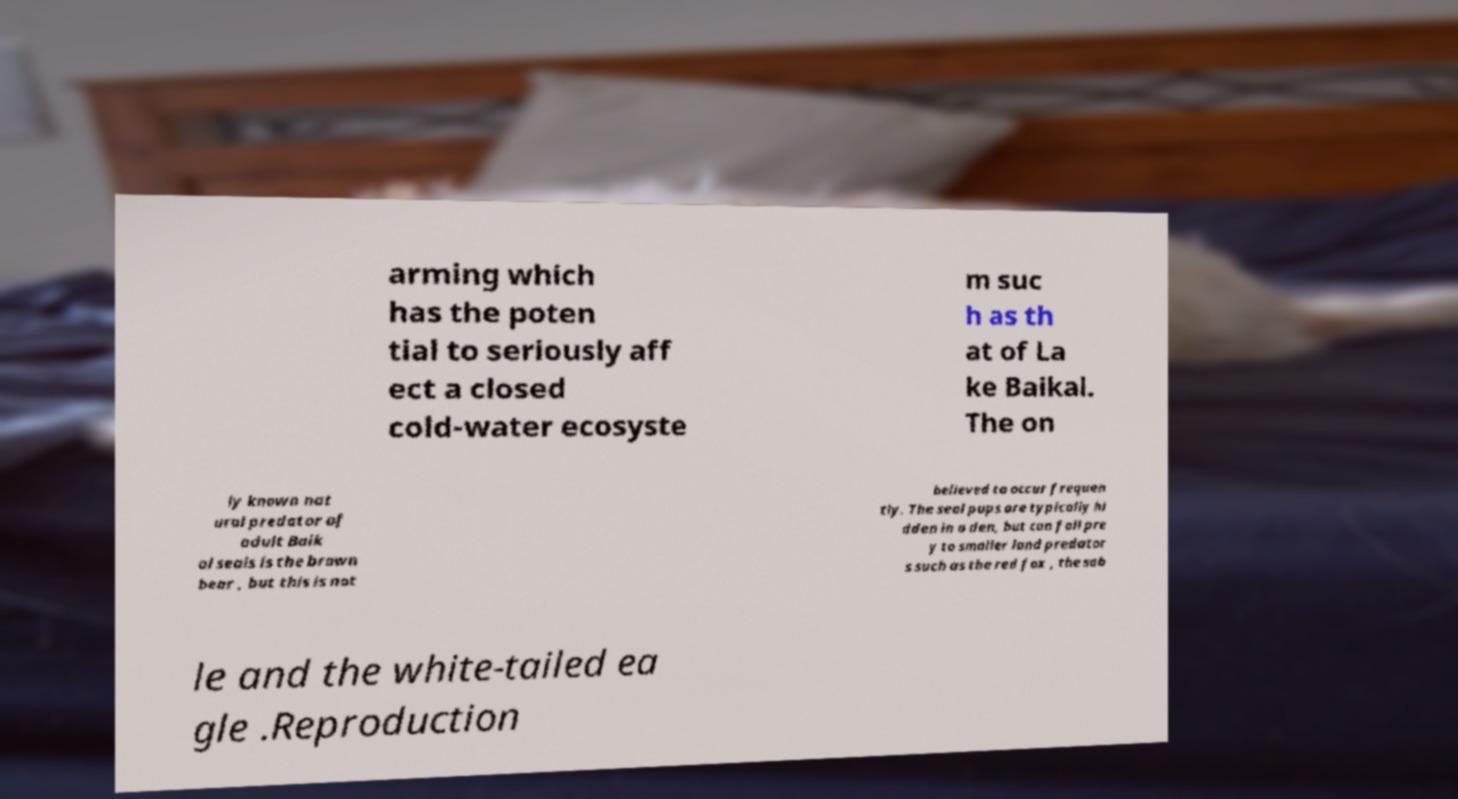Can you accurately transcribe the text from the provided image for me? arming which has the poten tial to seriously aff ect a closed cold-water ecosyste m suc h as th at of La ke Baikal. The on ly known nat ural predator of adult Baik al seals is the brown bear , but this is not believed to occur frequen tly. The seal pups are typically hi dden in a den, but can fall pre y to smaller land predator s such as the red fox , the sab le and the white-tailed ea gle .Reproduction 